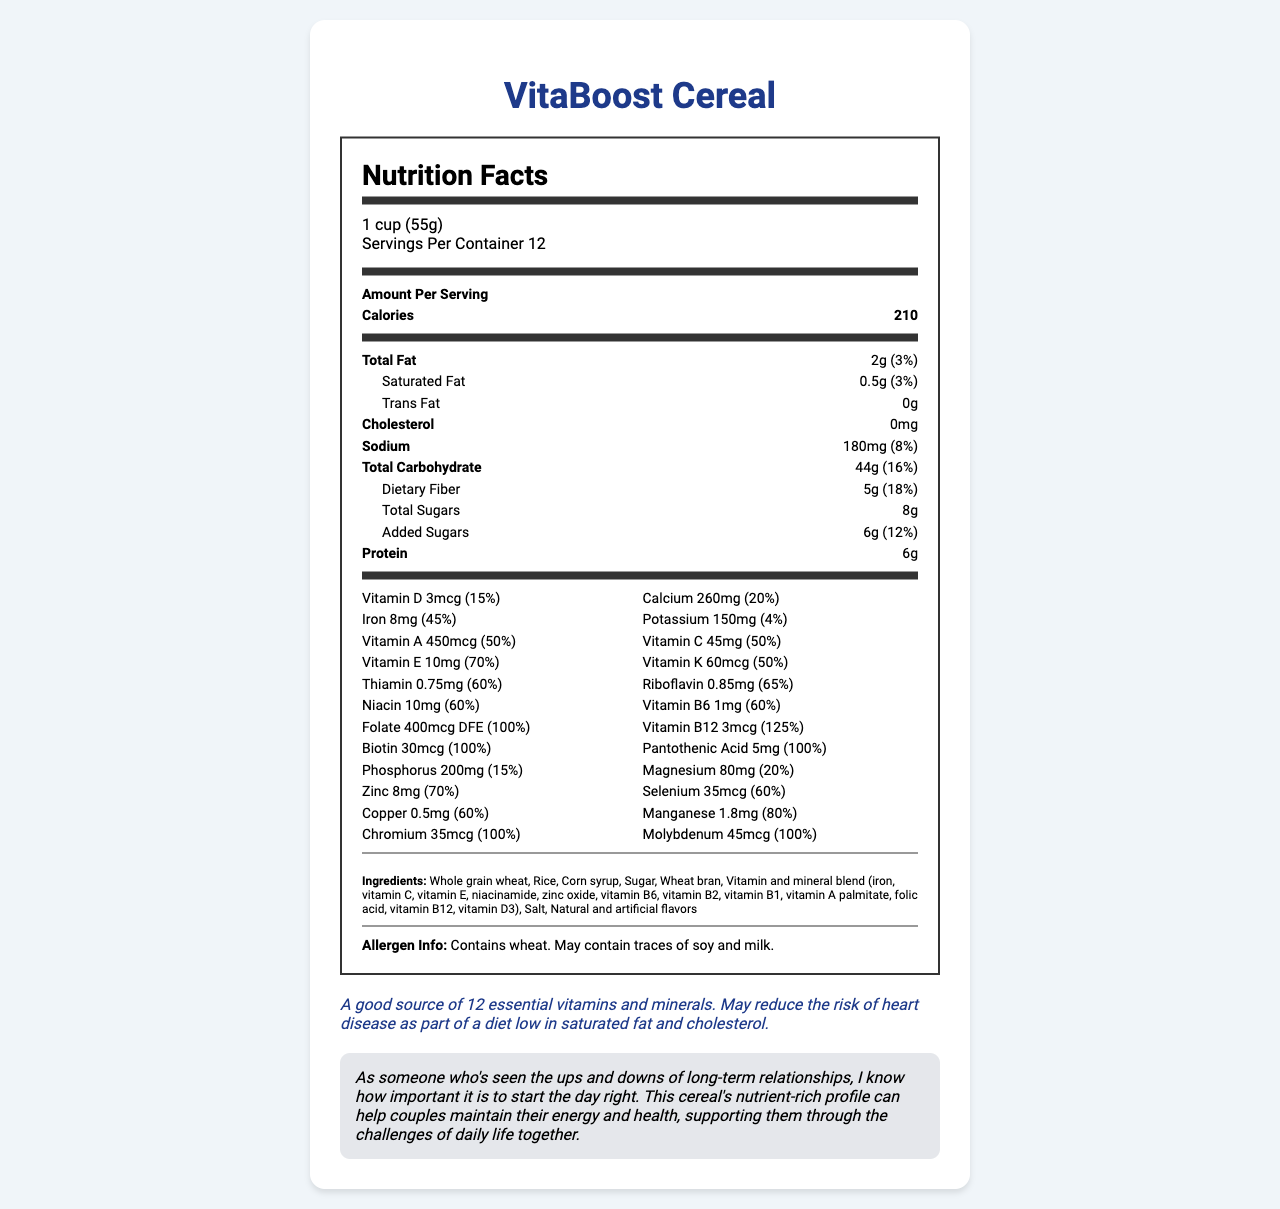what is the serving size of VitaBoost Cereal? The serving size is clearly mentioned at the top of the Nutrition Facts section in the document.
Answer: 1 cup (55g) how many servings are in one container? The number of servings per container is specified in the serving info section under the product name.
Answer: 12 how many calories are in one serving? The calories per serving are prominently displayed in the Amount Per Serving section of the document.
Answer: 210 calories what is the total fat content per serving? The total fat content is listed under the nutrients section and categorized as ‘Total Fat’.
Answer: 2g how much fiber is in one serving? The amount of dietary fiber is listed under the nutrient section as 'Dietary Fiber.'
Answer: 5g what is the amount of added sugars in one serving? The amount of added sugars is specified under the sub-nutrient section of Total Sugars.
Answer: 6g which vitamin has the highest daily value percentage? A. Vitamin A B. Vitamin C C. Vitamin E D. Vitamin B12 Vitamin B12 has a daily value of 125%, which is the highest among the listed vitamins.
Answer: D which of the following minerals is present in the highest quantity? (Per serving) I. Calcium II. Iron III. Zinc IV. Magnesium The amount of Iron per serving is 8mg, which has the highest daily value percentage of 45%, indicating it's the most substantial in quantity among the listed minerals.
Answer: II. Iron is the cereal a good source of protein? With 6 grams of protein per serving, the cereal provides a moderate amount of protein, making it a good source.
Answer: Yes does the product contain any allergens? The allergen information indicates that the product contains wheat and may contain traces of soy and milk.
Answer: Yes summarize the main nutritional benefits of VitaBoost Cereal. The document highlights that VitaBoost Cereal is enriched with several vital nutrients while being low in fats and cholesterol, making it beneficial for maintaining energy, health, and potentially reducing heart disease risks.
Answer: VitaBoost Cereal is a vitamin-fortified breakfast cereal with a solid nutritional profile. Each serving contains a moderate amount of calories, low total fat, and no cholesterol. It is high in dietary fiber and protein while providing a wide range of essential vitamins and minerals. The cereal includes high daily values for several vitamins and minerals, including vitamin B12, biotin, pantothenic acid, and folate. Additionally, it contains essential nutrients like iron, calcium, magnesium, and zinc. The product also claims to be beneficial for heart health as part of a diet low in saturated fat and cholesterol. how many total grams of carbohydrates are in one serving? The total carbohydrate content is listed in the nutrient section.
Answer: 44g what ingredients are used in the cereal? The ingredient list is provided towards the bottom of the document.
Answer: Whole grain wheat, Rice, Corn syrup, Sugar, Wheat bran, Vitamin and mineral blend (iron, vitamin C, vitamin E, niacinamide, zinc oxide, vitamin B6, vitamin B2, vitamin B1, vitamin A palmitate, folic acid, vitamin B12, vitamin D3), Salt, Natural and artificial flavors what is the role of the sibling note in the document? The sibling note emphasizes how the nutrient-rich profile of the cereal can help improve energy and health, beneficial for those in long-term relationships.
Answer: To emphasize the importance of starting the day with a nutritionally rich meal, which can positively affect health and energy levels, thus supporting the challenges of daily life in relationships. how long has VitaBoost Cereal been on the market? The document does not provide any information about the market duration of VitaBoost Cereal.
Answer: Cannot be determined 